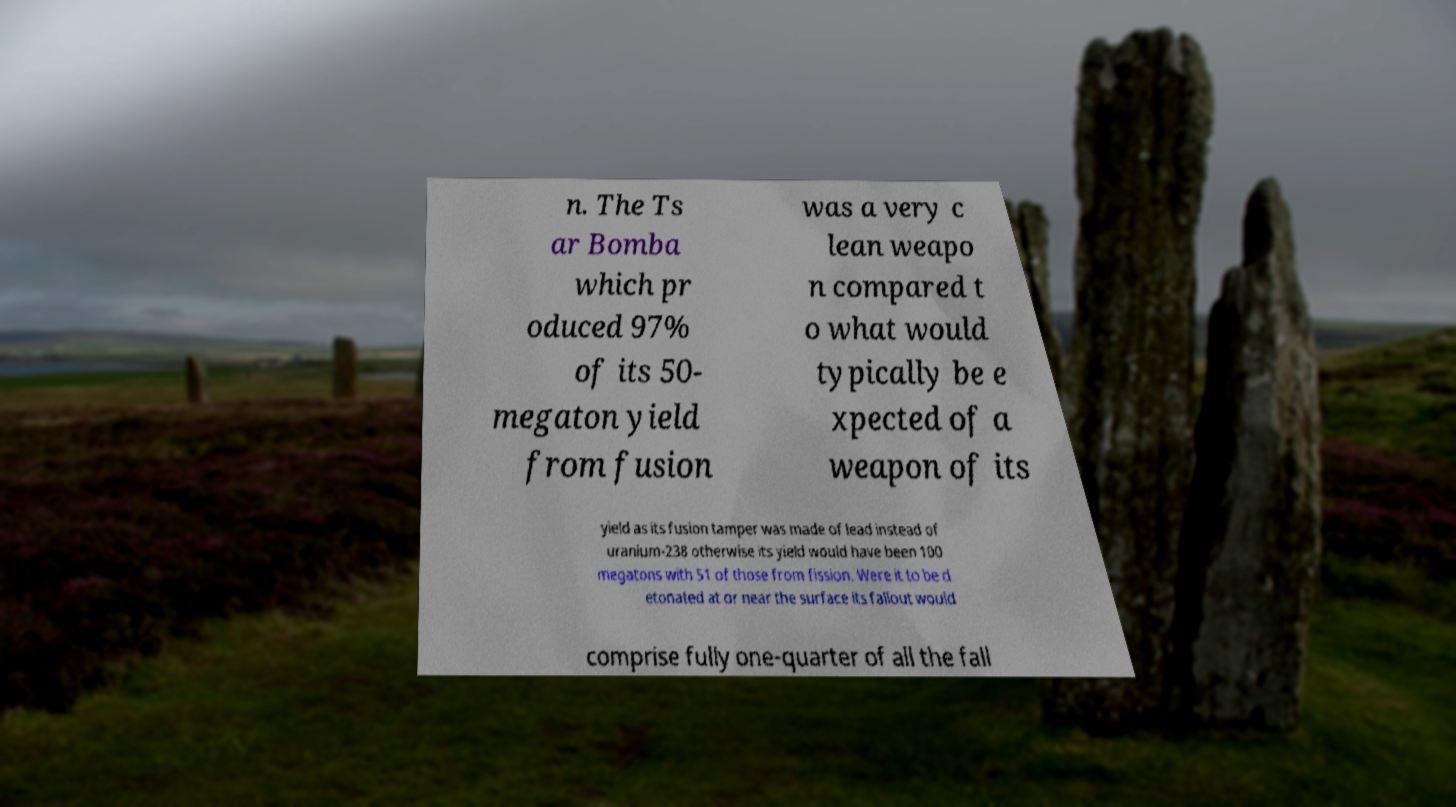What messages or text are displayed in this image? I need them in a readable, typed format. n. The Ts ar Bomba which pr oduced 97% of its 50- megaton yield from fusion was a very c lean weapo n compared t o what would typically be e xpected of a weapon of its yield as its fusion tamper was made of lead instead of uranium-238 otherwise its yield would have been 100 megatons with 51 of those from fission. Were it to be d etonated at or near the surface its fallout would comprise fully one-quarter of all the fall 